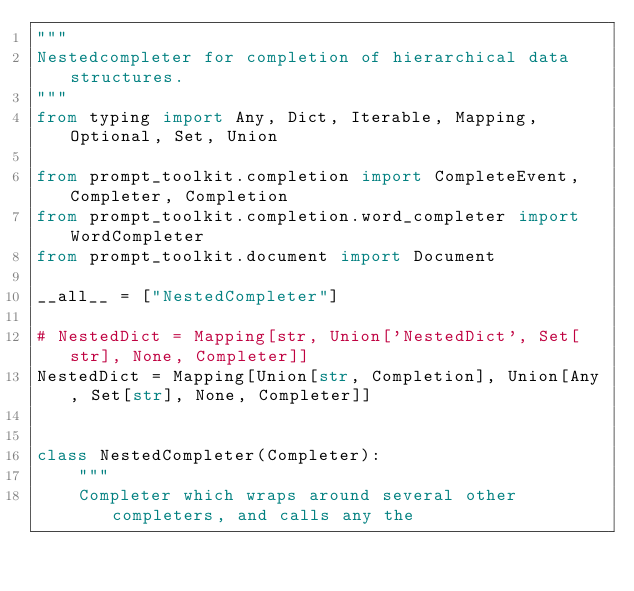Convert code to text. <code><loc_0><loc_0><loc_500><loc_500><_Python_>"""
Nestedcompleter for completion of hierarchical data structures.
"""
from typing import Any, Dict, Iterable, Mapping, Optional, Set, Union

from prompt_toolkit.completion import CompleteEvent, Completer, Completion
from prompt_toolkit.completion.word_completer import WordCompleter
from prompt_toolkit.document import Document

__all__ = ["NestedCompleter"]

# NestedDict = Mapping[str, Union['NestedDict', Set[str], None, Completer]]
NestedDict = Mapping[Union[str, Completion], Union[Any, Set[str], None, Completer]]


class NestedCompleter(Completer):
    """
    Completer which wraps around several other completers, and calls any the</code> 